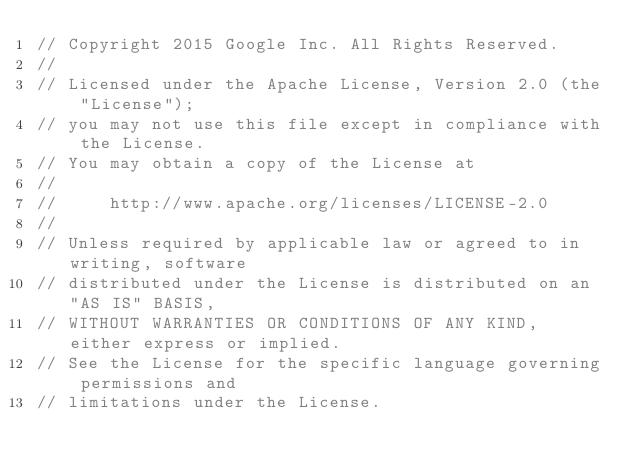<code> <loc_0><loc_0><loc_500><loc_500><_JavaScript_>// Copyright 2015 Google Inc. All Rights Reserved.
//
// Licensed under the Apache License, Version 2.0 (the "License");
// you may not use this file except in compliance with the License.
// You may obtain a copy of the License at
//
//     http://www.apache.org/licenses/LICENSE-2.0
//
// Unless required by applicable law or agreed to in writing, software
// distributed under the License is distributed on an "AS IS" BASIS,
// WITHOUT WARRANTIES OR CONDITIONS OF ANY KIND, either express or implied.
// See the License for the specific language governing permissions and
// limitations under the License.
</code> 